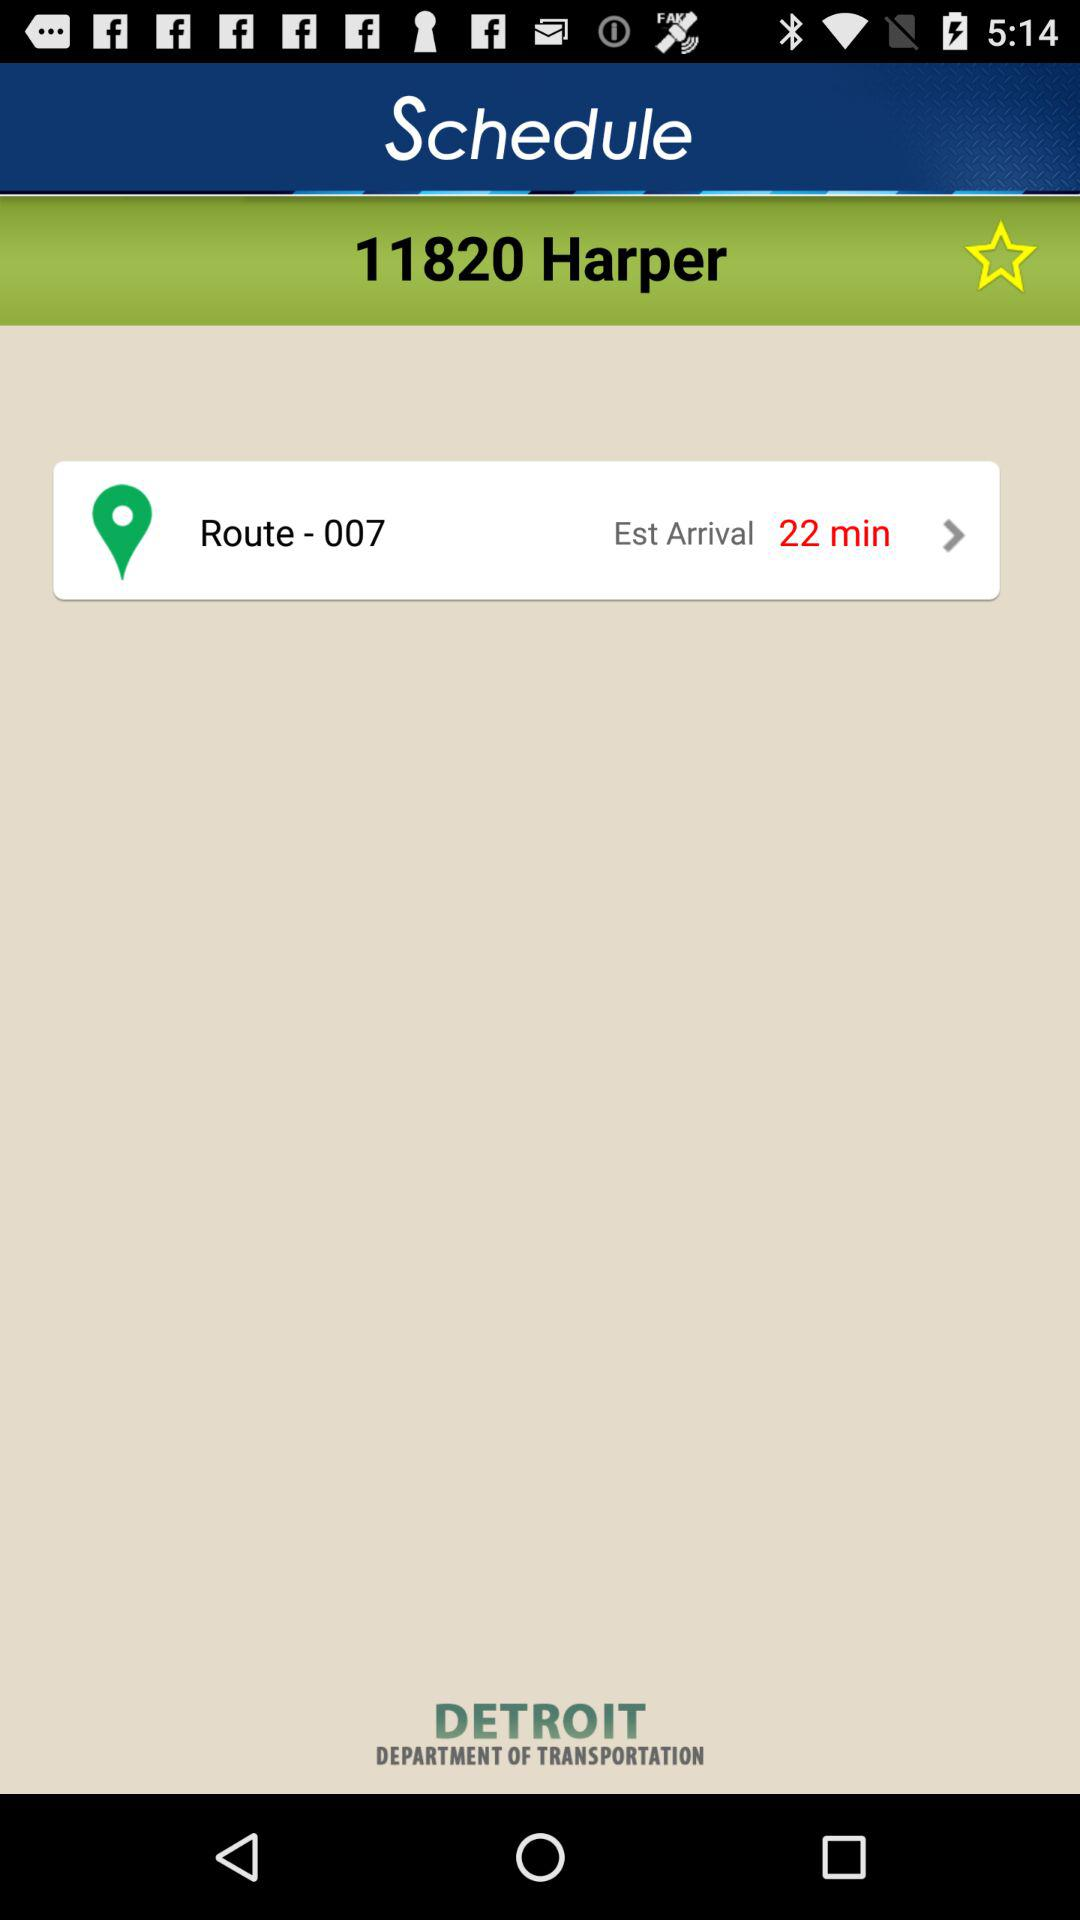What is the time for Est's arrival? The time is 22 minutes. 